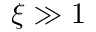<formula> <loc_0><loc_0><loc_500><loc_500>\xi \gg 1</formula> 